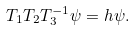Convert formula to latex. <formula><loc_0><loc_0><loc_500><loc_500>T _ { 1 } T _ { 2 } T _ { 3 } ^ { - 1 } \psi = h \psi .</formula> 